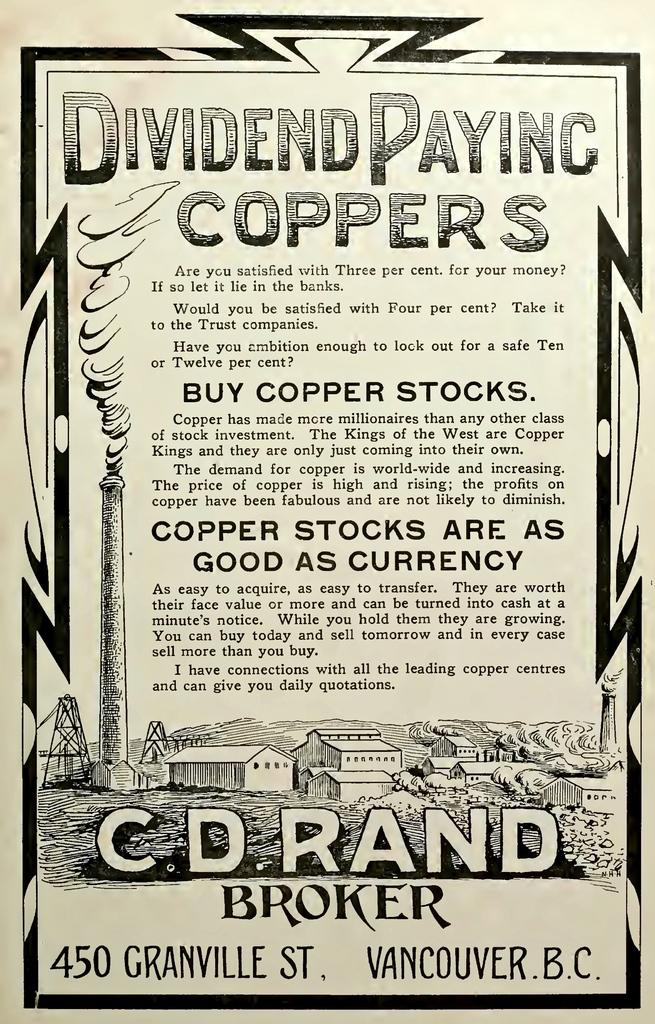Provide a one-sentence caption for the provided image. An old stock dividend paper for coppers from Vancouver, B.C. 